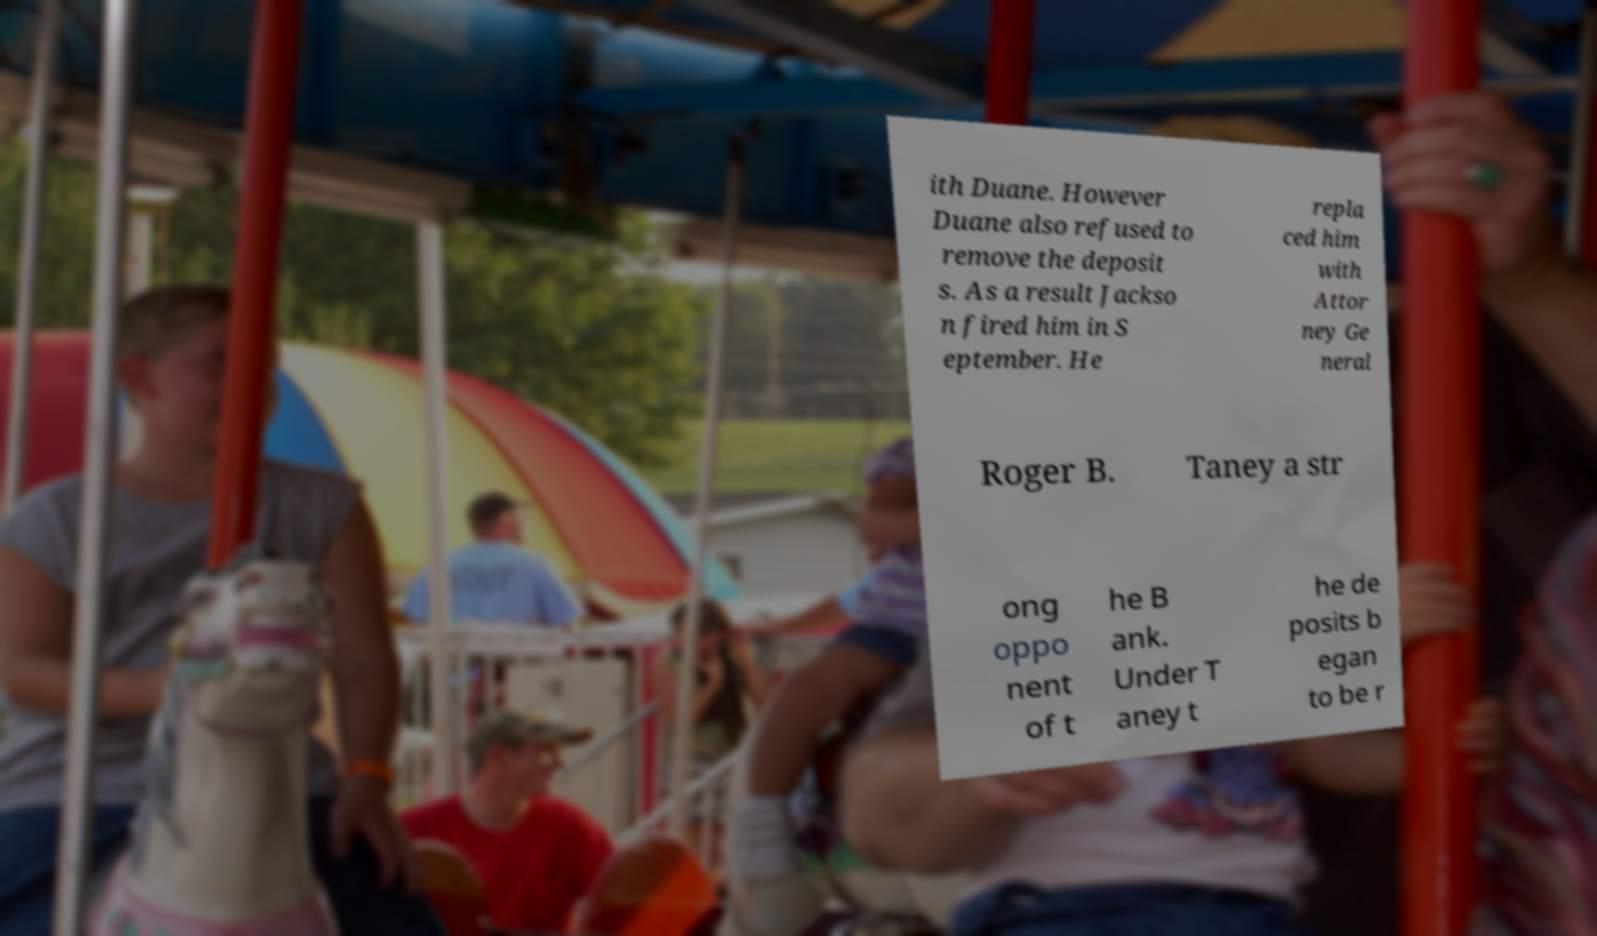Can you read and provide the text displayed in the image?This photo seems to have some interesting text. Can you extract and type it out for me? ith Duane. However Duane also refused to remove the deposit s. As a result Jackso n fired him in S eptember. He repla ced him with Attor ney Ge neral Roger B. Taney a str ong oppo nent of t he B ank. Under T aney t he de posits b egan to be r 